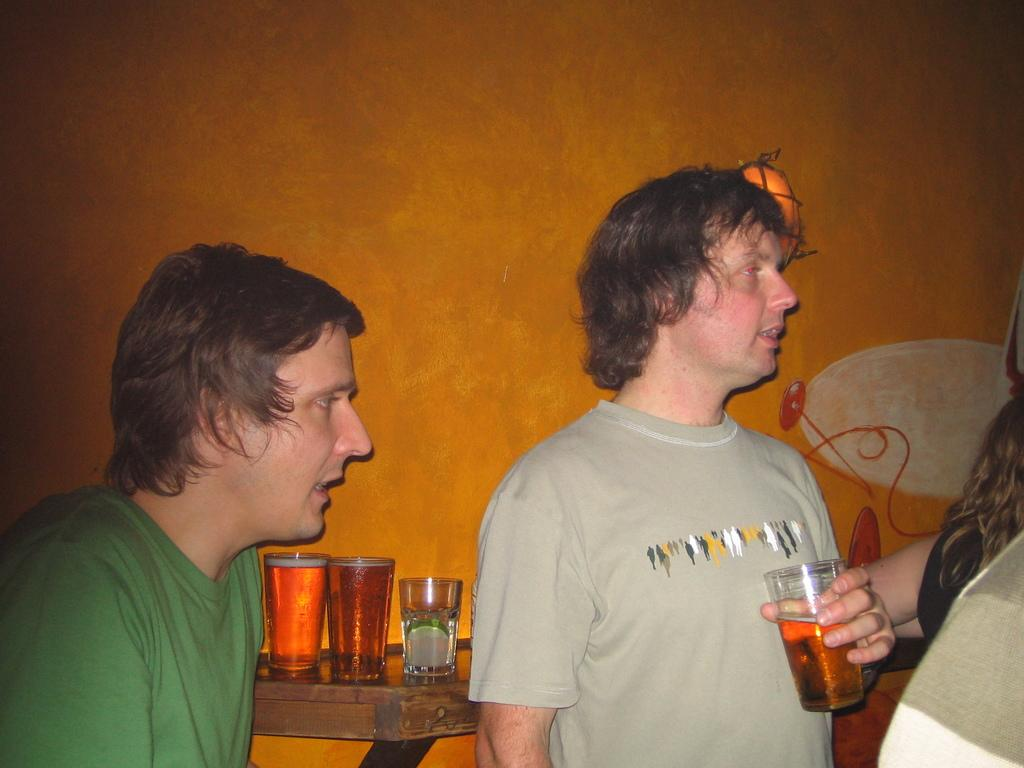What color is the wall that can be seen in the image? There is an orange color wall in the image. Who or what is in front of the wall in the image? There are people standing in the image. What piece of furniture is present in the image? There is a table in the image. How many glasses are on the table in the image? There are three glasses on the table. Is there a porter carrying luggage in the image? There is no porter carrying luggage in the image. Can you see a locket hanging from the wall in the image? There is no locket hanging from the wall in the image. 